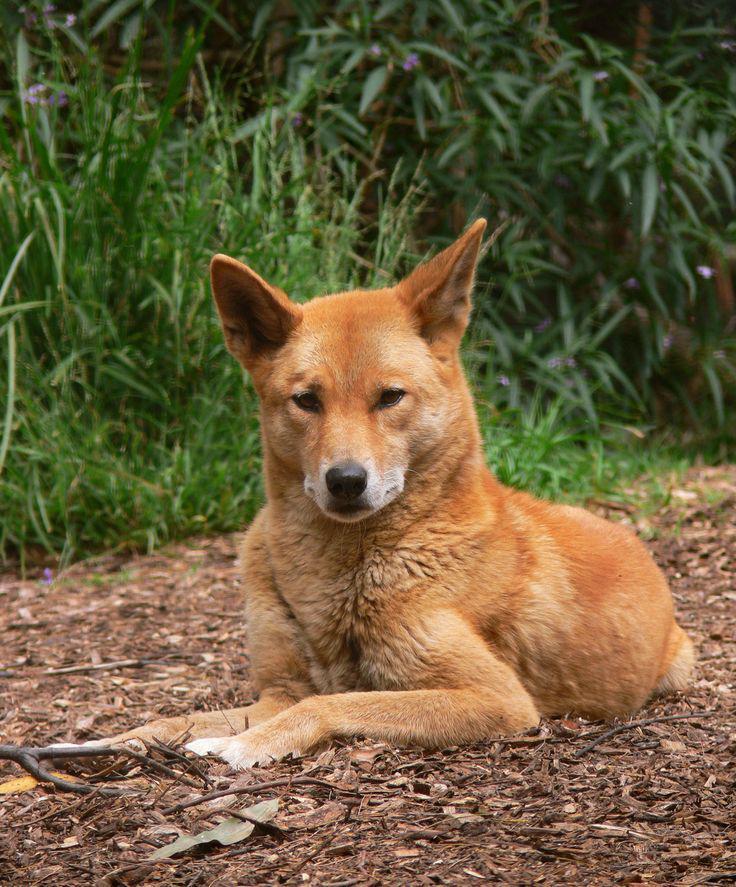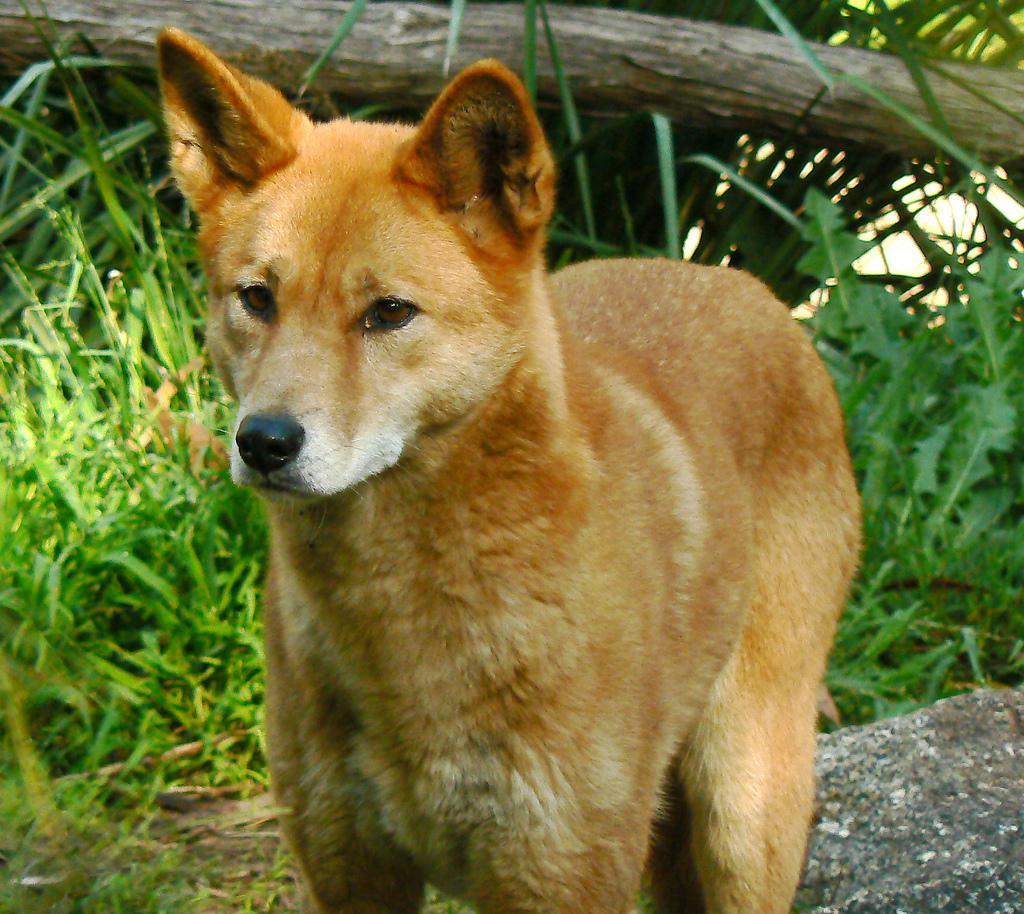The first image is the image on the left, the second image is the image on the right. Analyze the images presented: Is the assertion "The wild dog in the image on the left is lying on the ground." valid? Answer yes or no. Yes. 